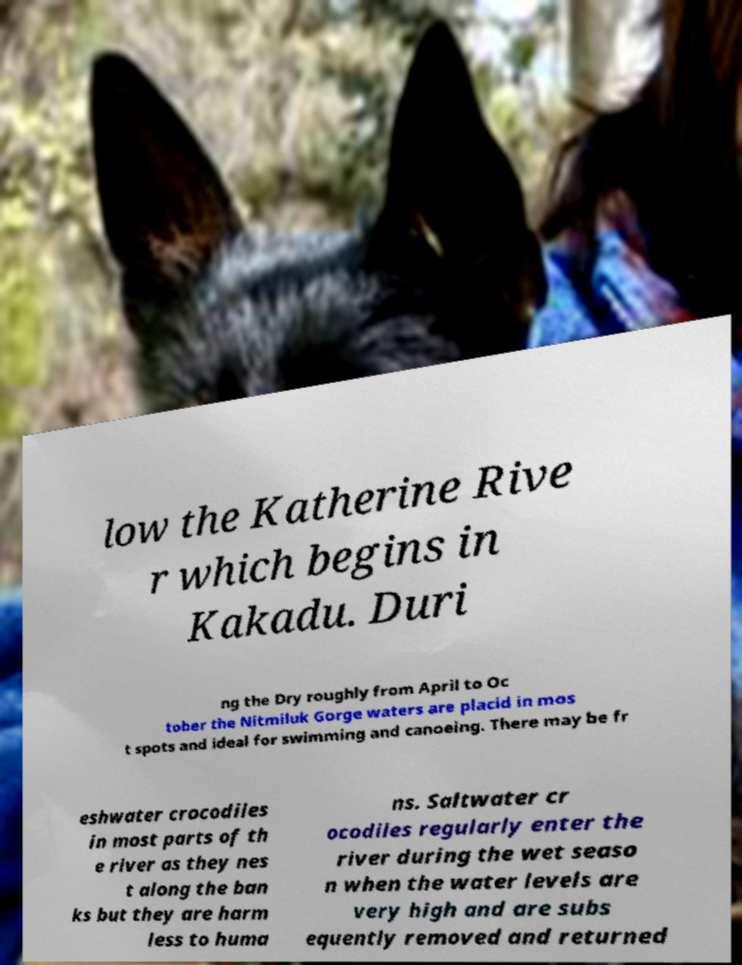Could you extract and type out the text from this image? low the Katherine Rive r which begins in Kakadu. Duri ng the Dry roughly from April to Oc tober the Nitmiluk Gorge waters are placid in mos t spots and ideal for swimming and canoeing. There may be fr eshwater crocodiles in most parts of th e river as they nes t along the ban ks but they are harm less to huma ns. Saltwater cr ocodiles regularly enter the river during the wet seaso n when the water levels are very high and are subs equently removed and returned 